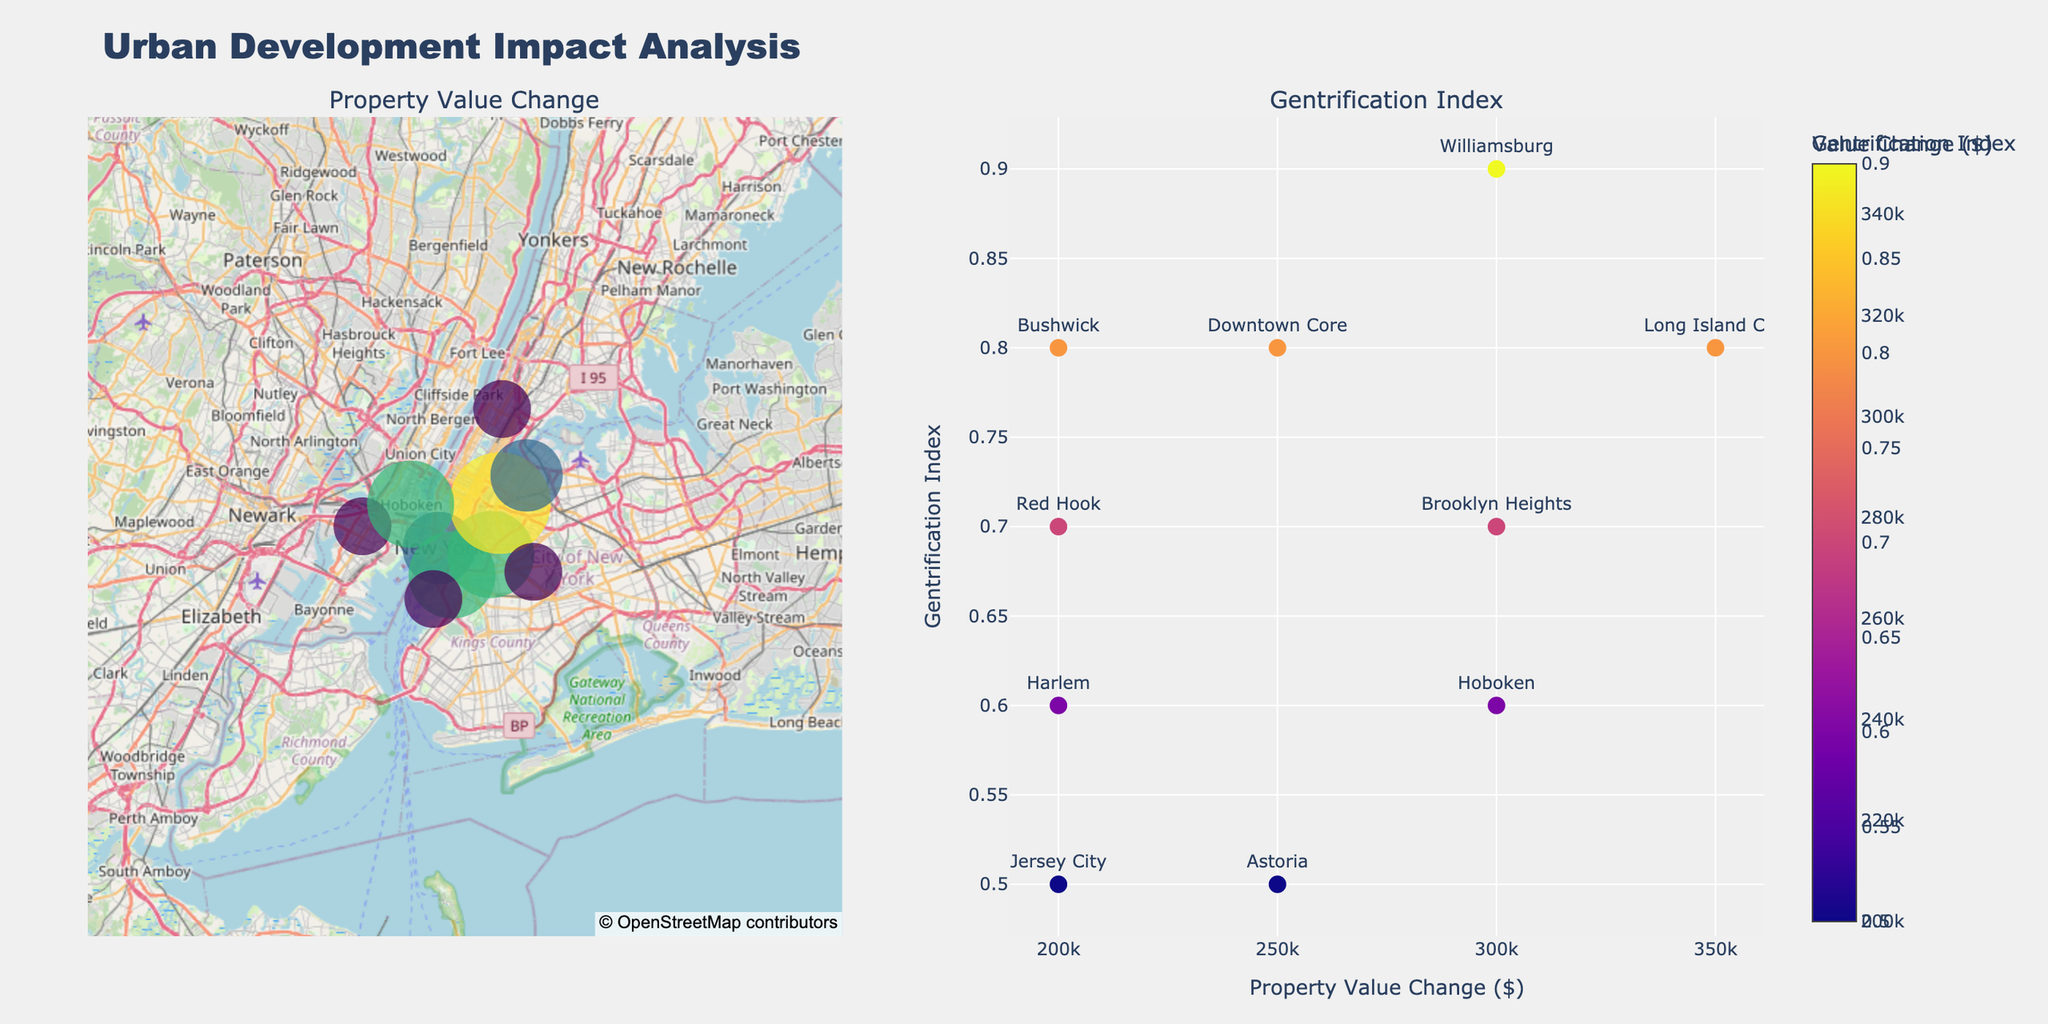What is the title of the figure? The title of the figure is prominently displayed at the top. It reads "Urban Development Impact Analysis".
Answer: Urban Development Impact Analysis How many neighborhoods are shown on the figure? To determine the number of neighborhoods, count the distinct markers on both the map and scatter plot; each one represents a different neighborhood. There are a total of 10 neighborhoods indicated.
Answer: 10 Which neighborhood experienced the highest property value change post-project? On the scatter plot, identify the point farthest to the right, as it represents the highest property value change. The text for the farthest right marker shows "Brooklyn Heights".
Answer: Brooklyn Heights Which neighborhood has the highest Gentrification Index? In the scatter plot, look for the point that is highest along the y-axis. The associated text shows "Williamsburg".
Answer: Williamsburg Which neighborhood had the lowest pre-project value and what was it? On the map plot, hover over the markers to see the neighborhood details. Identify the one with the smallest pre-project value. "Bushwick" had the lowest pre-project value of $200,000.
Answer: Bushwick, $200,000 What is the color used to represent the highest property value change on the map? The color scale displayed on the map plot uses "Viridis" colors. Hover over the marker with the highest size to identify the color used. It's a shade of yellow-green due to high value change.
Answer: Yellow-Green What is the range of the Gentrification Index in the scatter plot? Examine the y-axis of the scatter plot to determine the minimum and maximum values. The minimum Gentrification Index is 0.5 and the maximum is 0.9.
Answer: 0.5 to 0.9 Which two neighborhoods have the same Gentrification Index but different property value changes? Find markers on the scatter plot with the same y-axis value (Gentrification Index). "Harlem" and "Hoboken" both have a Gentrification Index of 0.6 but have different x-axis (property value change).
Answer: Harlem and Hoboken What is the average post-project property value among all neighborhoods? Sum the post-project values for all neighborhoods and divide by the number of neighborhoods: (750000+550000+900000+700000+800000+500000+850000+450000+600000+400000)/10 = 650000.
Answer: $650,000 